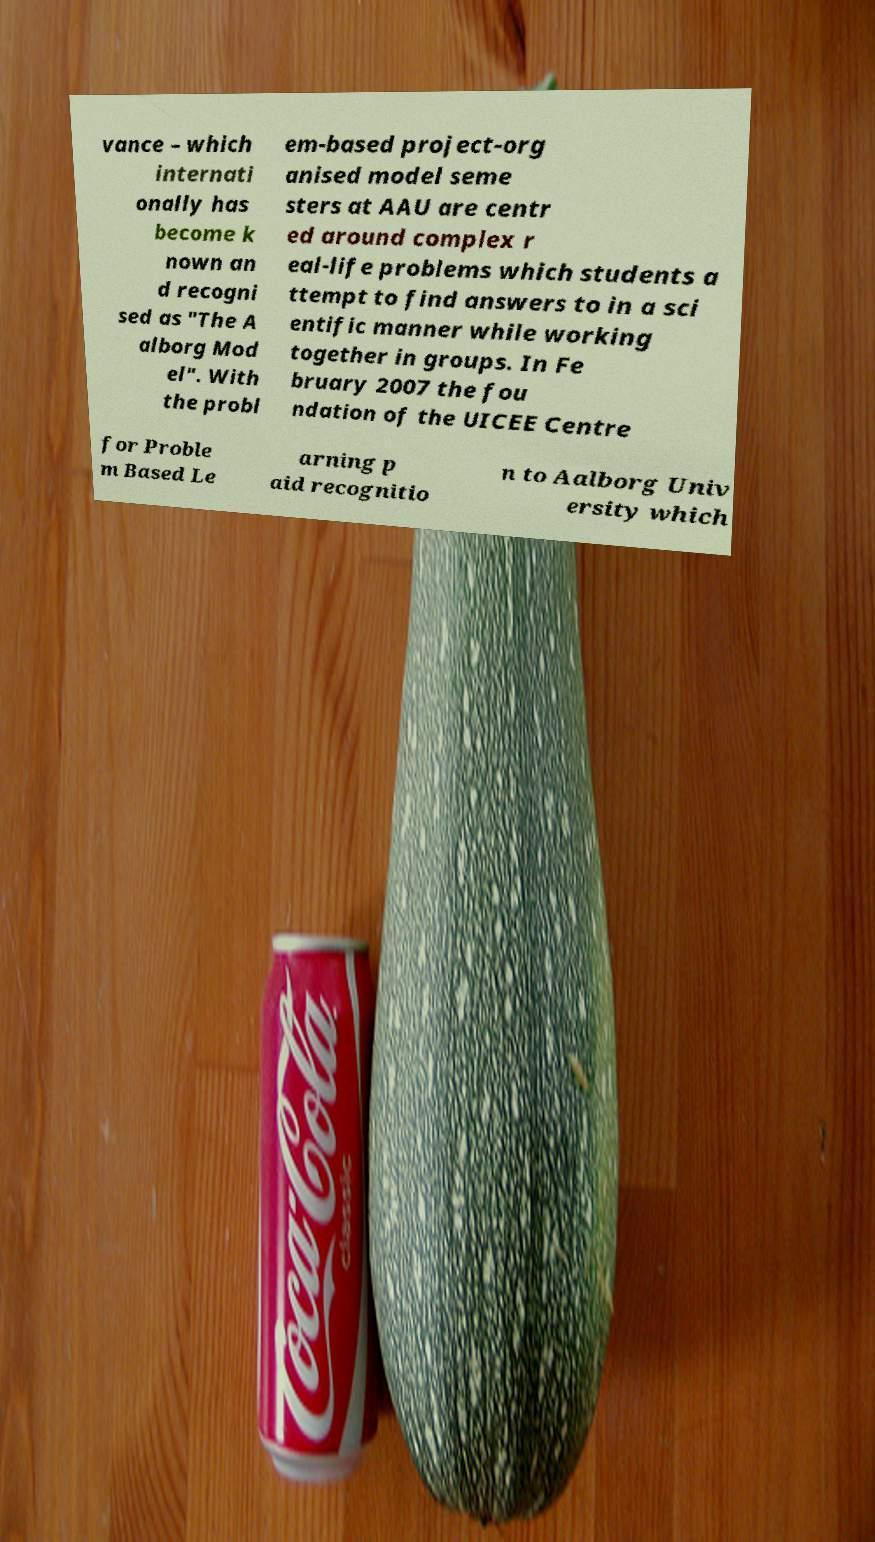For documentation purposes, I need the text within this image transcribed. Could you provide that? vance – which internati onally has become k nown an d recogni sed as "The A alborg Mod el". With the probl em-based project-org anised model seme sters at AAU are centr ed around complex r eal-life problems which students a ttempt to find answers to in a sci entific manner while working together in groups. In Fe bruary 2007 the fou ndation of the UICEE Centre for Proble m Based Le arning p aid recognitio n to Aalborg Univ ersity which 